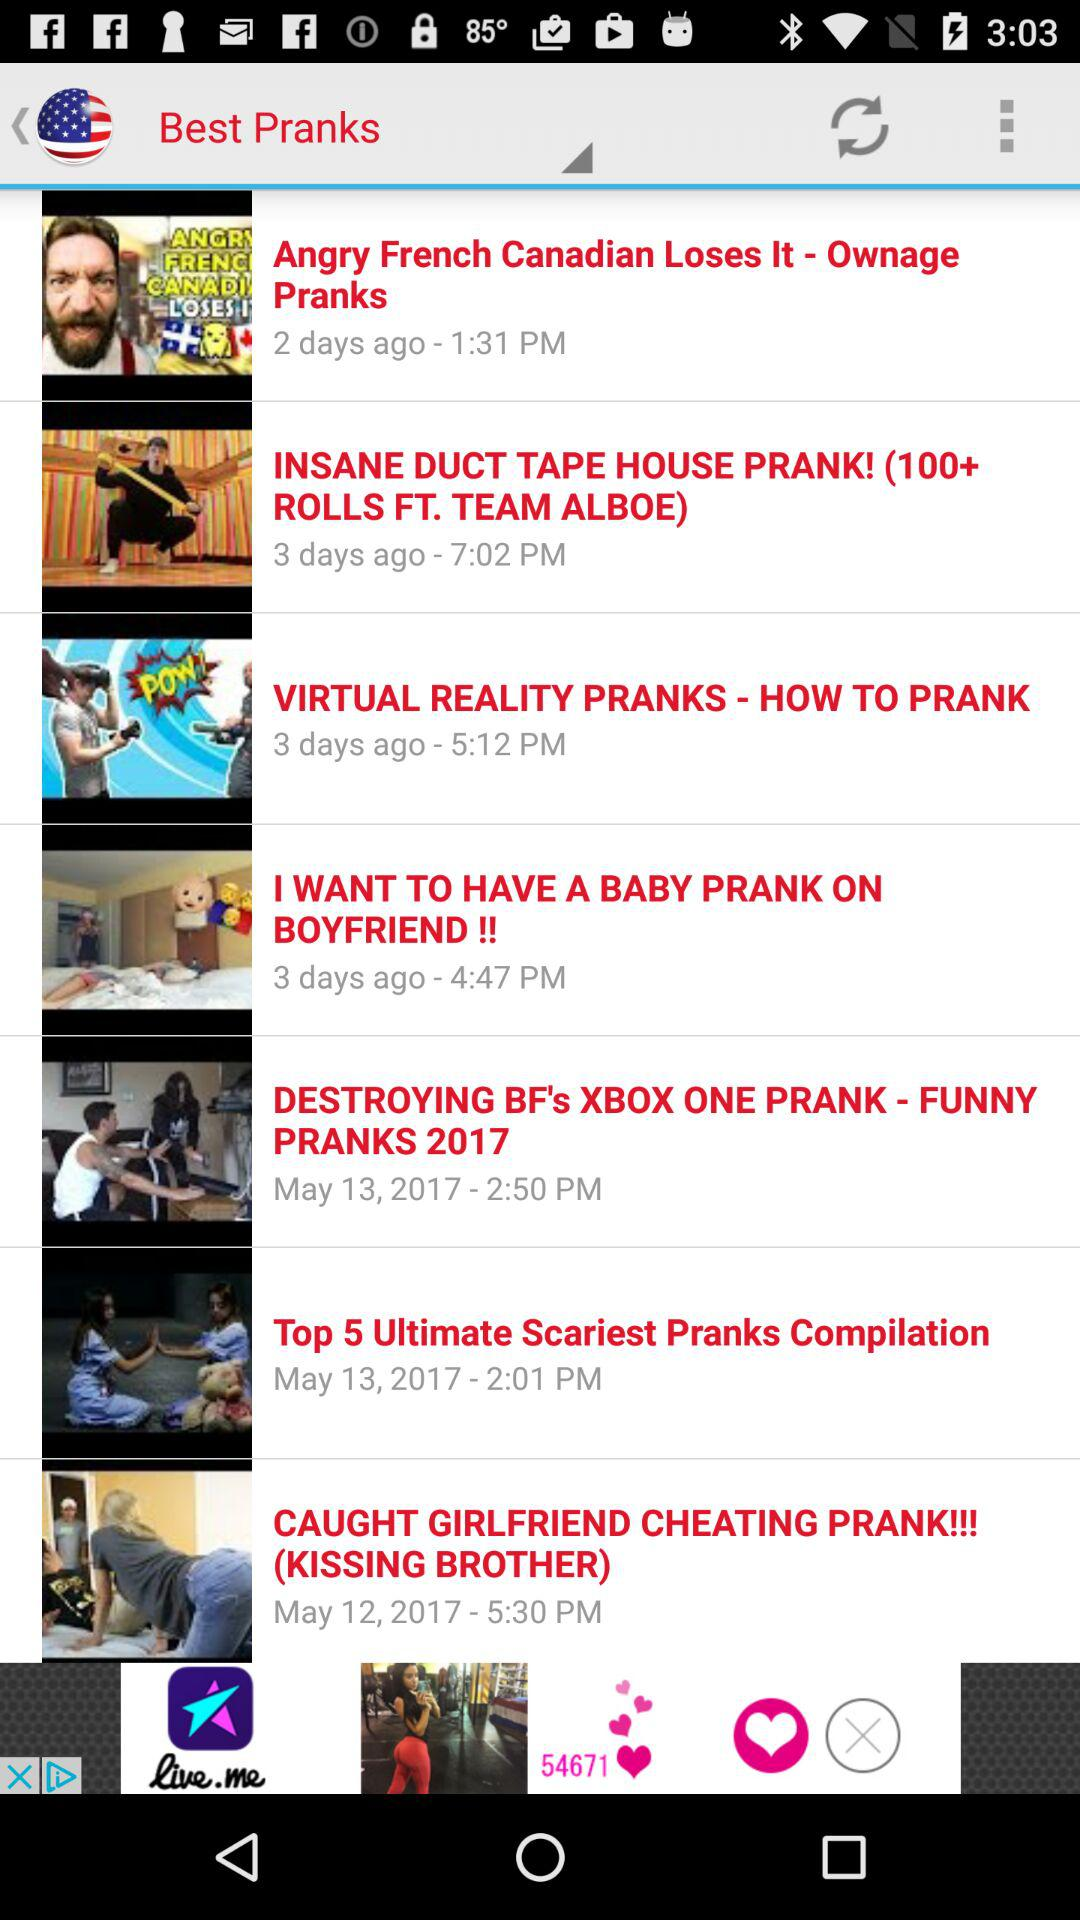What is the posted time of the "VIRTUAL REALITY PRANKS" video? The posted time is 5:12 p.m. 